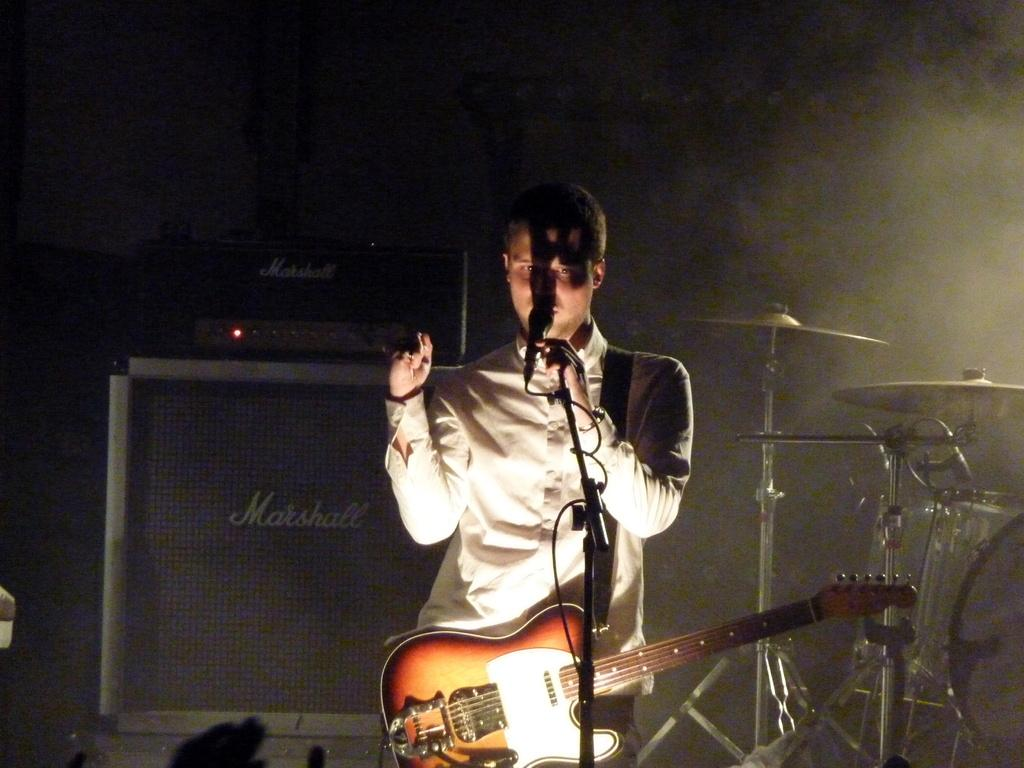Who is the main subject in the image? There is a man in the image. What is the man holding in the image? The man is holding a microphone. What other item is the man carrying in the image? The man is carrying a guitar. What can be seen in the background of the image? There is equipment and musical instruments in the background of the image. What type of animal can be seen in the image? There is no animal present in the image. How many kilograms of mass does the microphone have in the image? The mass of the microphone cannot be determined from the image alone, as it is a two-dimensional representation. 